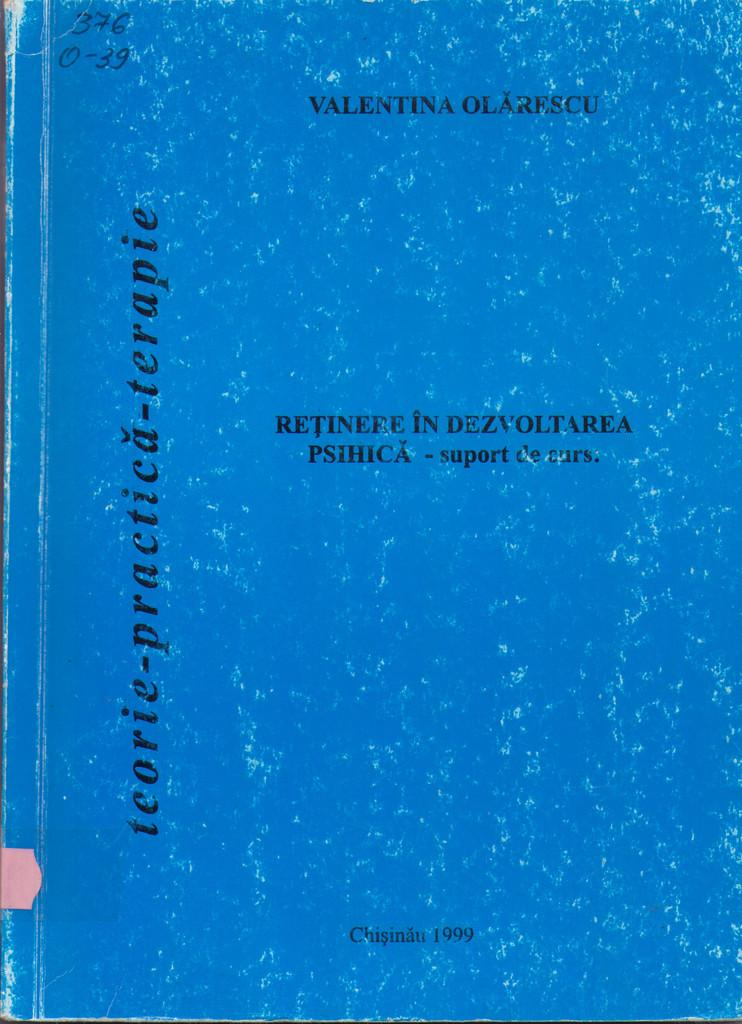<image>
Render a clear and concise summary of the photo. The cover of the book named Teoric Priacticu terapie by valentina olarescu. 